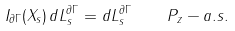<formula> <loc_0><loc_0><loc_500><loc_500>I _ { \partial \Gamma } ( X _ { s } ) \, d L _ { s } ^ { \| \partial \Gamma \| } = d L _ { s } ^ { \| \partial \Gamma \| } \quad P _ { z } - a . s .</formula> 